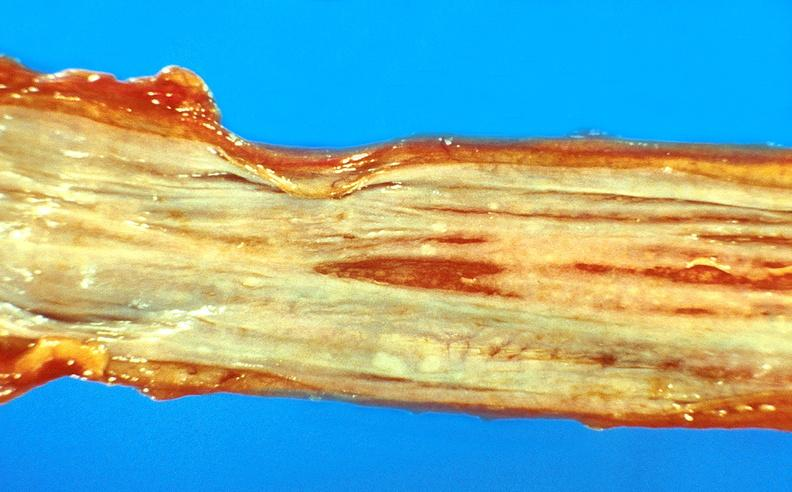what is present?
Answer the question using a single word or phrase. Gastrointestinal 